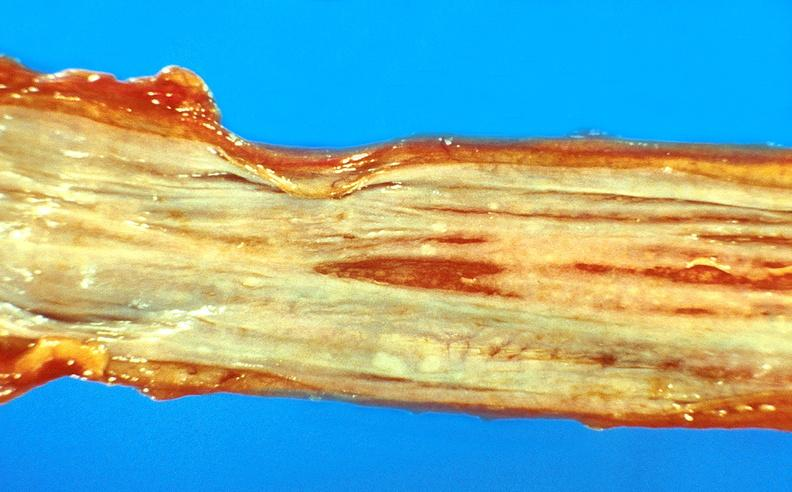what is present?
Answer the question using a single word or phrase. Gastrointestinal 